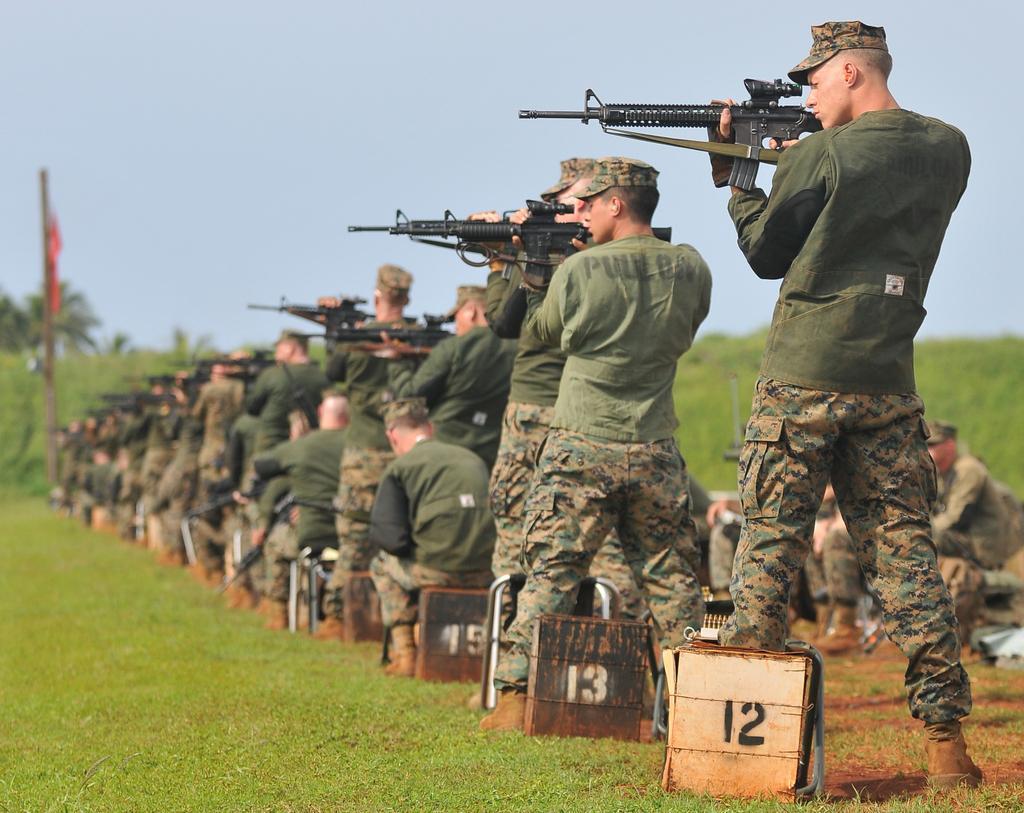Please provide a concise description of this image. On the right side, there are persons in uniform, holding guns. Some of them are sitting and the rest of them are standing on the ground, on which there is grass and there are boards arranged. In the background, there is a pole, there are trees, plants and there are clouds in the sky. 